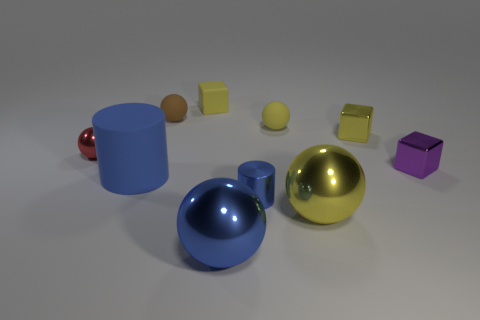Subtract all yellow blocks. How many yellow balls are left? 2 Subtract all small spheres. How many spheres are left? 2 Subtract all red spheres. How many spheres are left? 4 Subtract 3 balls. How many balls are left? 2 Subtract all cyan blocks. Subtract all brown balls. How many blocks are left? 3 Subtract all cylinders. How many objects are left? 8 Subtract all brown rubber cylinders. Subtract all blue metallic cylinders. How many objects are left? 9 Add 5 small purple blocks. How many small purple blocks are left? 6 Add 6 big brown matte spheres. How many big brown matte spheres exist? 6 Subtract 0 yellow cylinders. How many objects are left? 10 